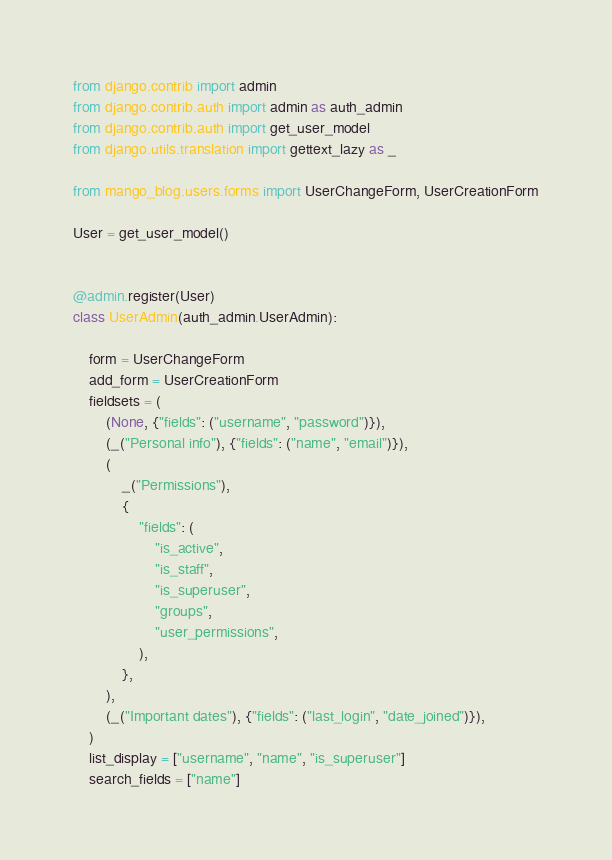<code> <loc_0><loc_0><loc_500><loc_500><_Python_>from django.contrib import admin
from django.contrib.auth import admin as auth_admin
from django.contrib.auth import get_user_model
from django.utils.translation import gettext_lazy as _

from mango_blog.users.forms import UserChangeForm, UserCreationForm

User = get_user_model()


@admin.register(User)
class UserAdmin(auth_admin.UserAdmin):

    form = UserChangeForm
    add_form = UserCreationForm
    fieldsets = (
        (None, {"fields": ("username", "password")}),
        (_("Personal info"), {"fields": ("name", "email")}),
        (
            _("Permissions"),
            {
                "fields": (
                    "is_active",
                    "is_staff",
                    "is_superuser",
                    "groups",
                    "user_permissions",
                ),
            },
        ),
        (_("Important dates"), {"fields": ("last_login", "date_joined")}),
    )
    list_display = ["username", "name", "is_superuser"]
    search_fields = ["name"]
</code> 